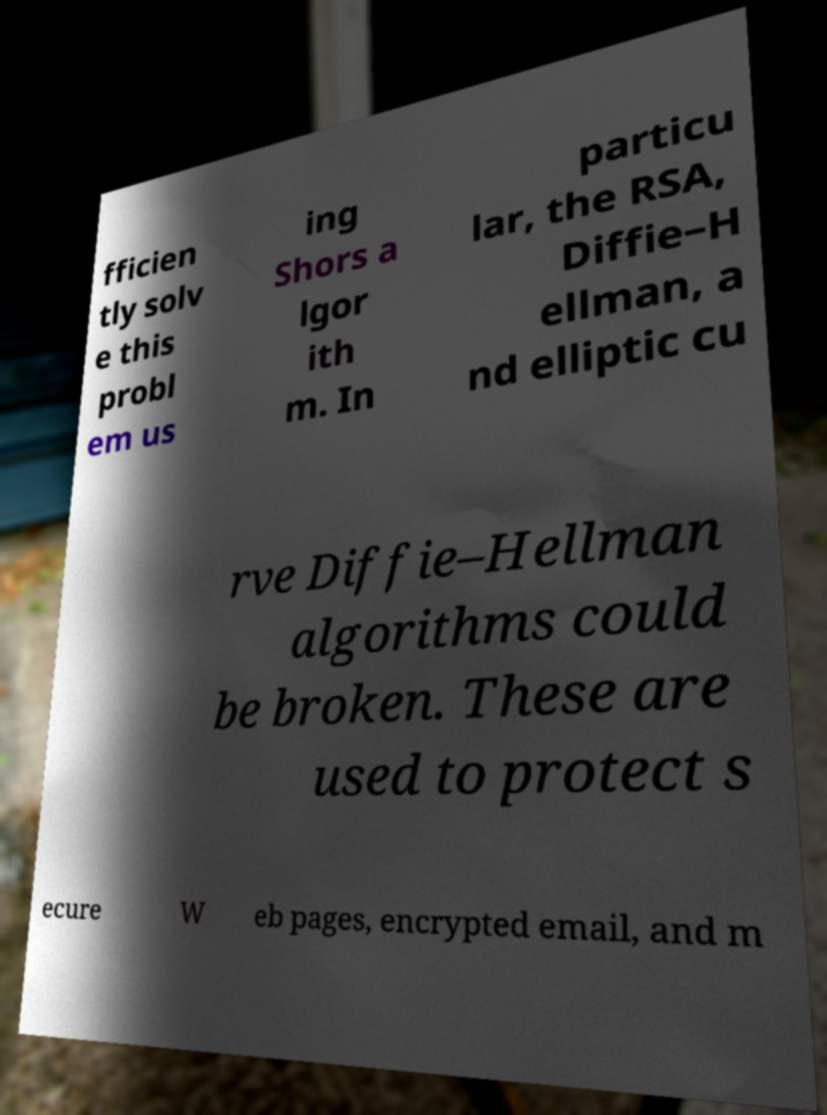For documentation purposes, I need the text within this image transcribed. Could you provide that? fficien tly solv e this probl em us ing Shors a lgor ith m. In particu lar, the RSA, Diffie–H ellman, a nd elliptic cu rve Diffie–Hellman algorithms could be broken. These are used to protect s ecure W eb pages, encrypted email, and m 